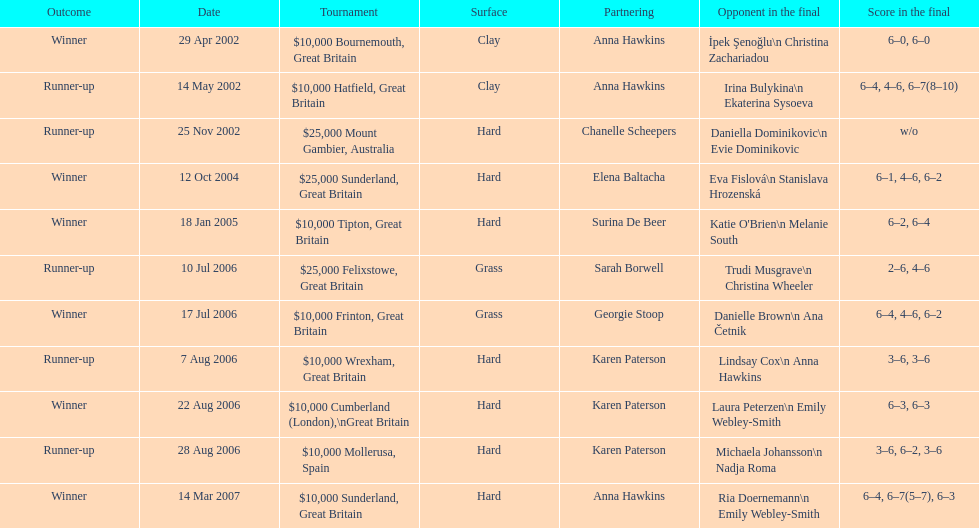What is the number of contests jane o'donoghue has competed in? 11. 